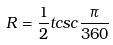Convert formula to latex. <formula><loc_0><loc_0><loc_500><loc_500>R = \frac { 1 } { 2 } t c s c \frac { \pi } { 3 6 0 }</formula> 